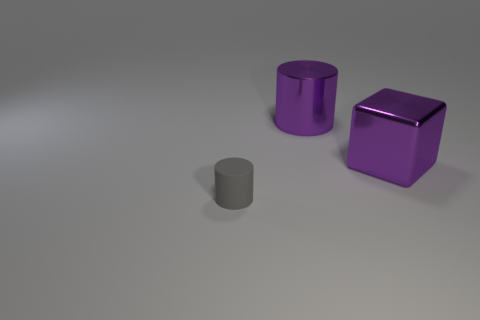Are there an equal number of big cylinders in front of the gray object and gray rubber cylinders?
Ensure brevity in your answer.  No. Are there any other things that have the same size as the purple cylinder?
Provide a short and direct response. Yes. What number of objects are either things or large red cubes?
Your answer should be compact. 3. The big thing that is the same material as the large purple cylinder is what shape?
Make the answer very short. Cube. What is the size of the gray thing that is in front of the cylinder on the right side of the small gray object?
Your response must be concise. Small. What number of large things are purple metallic things or blue rubber blocks?
Your answer should be very brief. 2. What number of other objects are the same color as the large metal cylinder?
Provide a short and direct response. 1. Do the metallic thing to the left of the metallic block and the gray cylinder in front of the purple cube have the same size?
Ensure brevity in your answer.  No. Is the purple cylinder made of the same material as the thing in front of the cube?
Your answer should be very brief. No. Are there more purple metal objects that are in front of the large purple cylinder than rubber things that are on the left side of the small rubber object?
Give a very brief answer. Yes. 